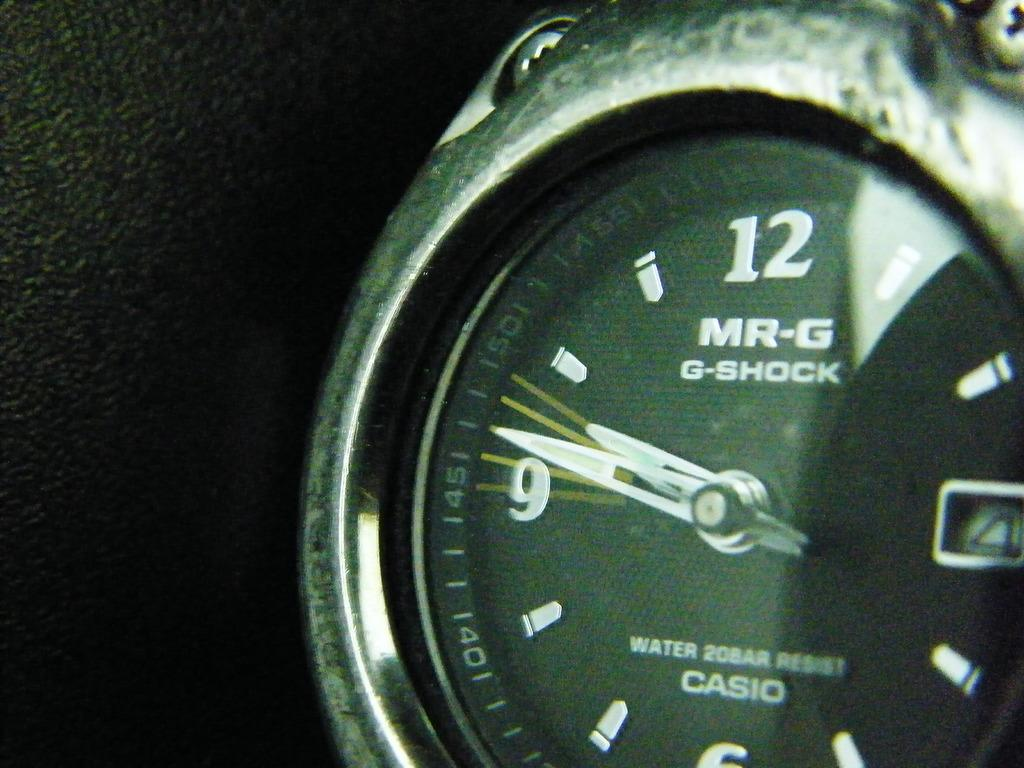<image>
Share a concise interpretation of the image provided. A black Casio watch has the number 12 on it's face. 